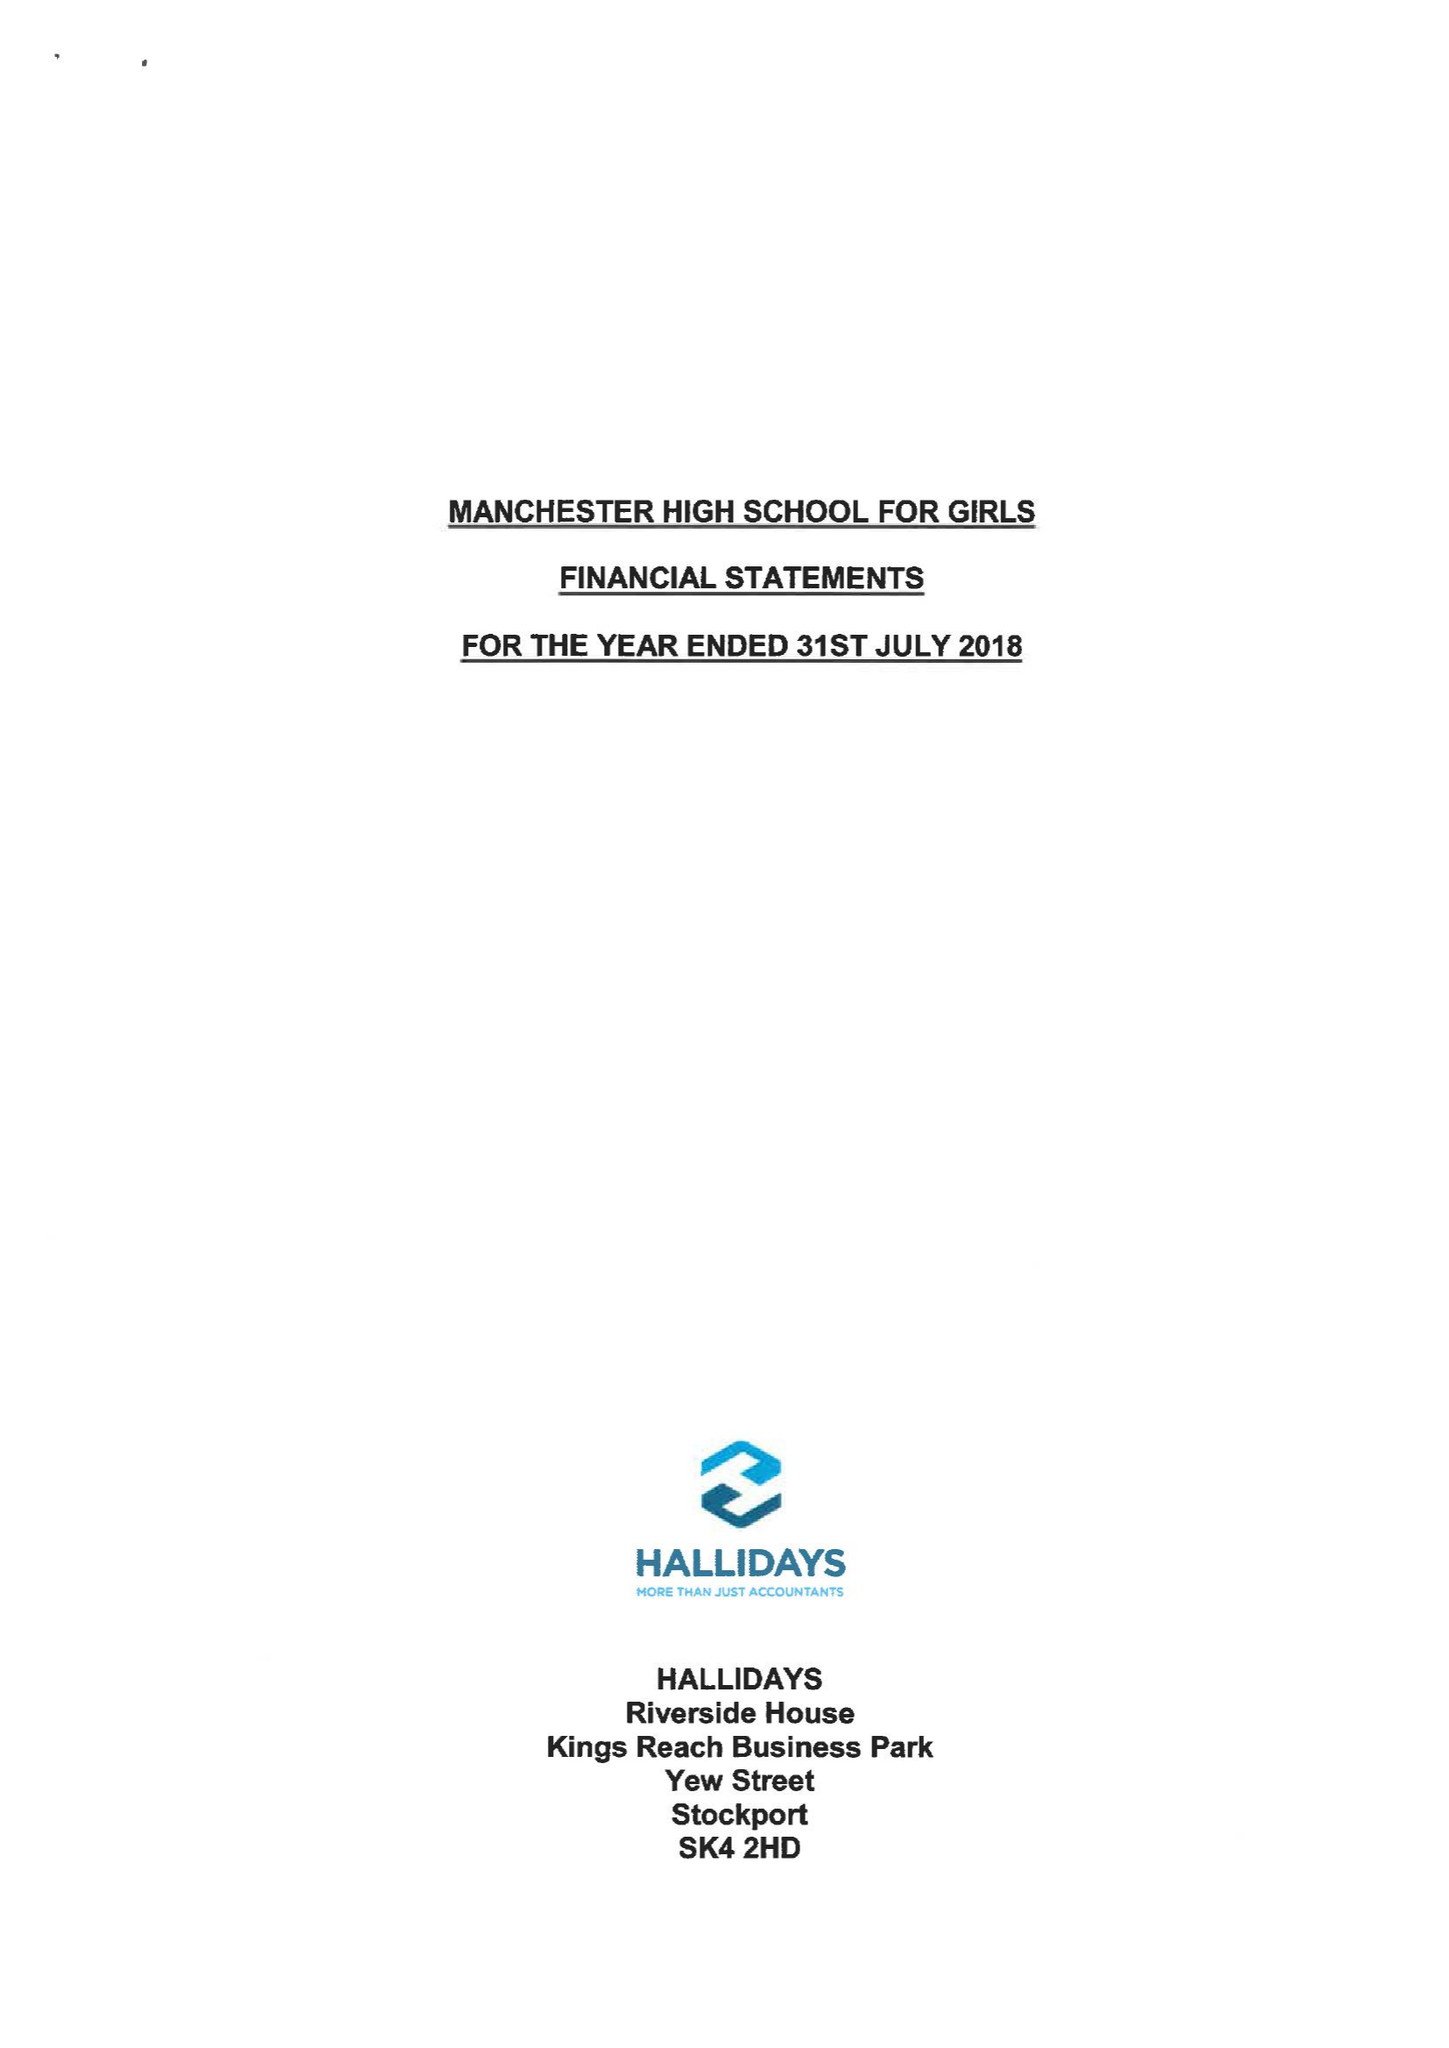What is the value for the charity_name?
Answer the question using a single word or phrase. Manchester High School For Girls 